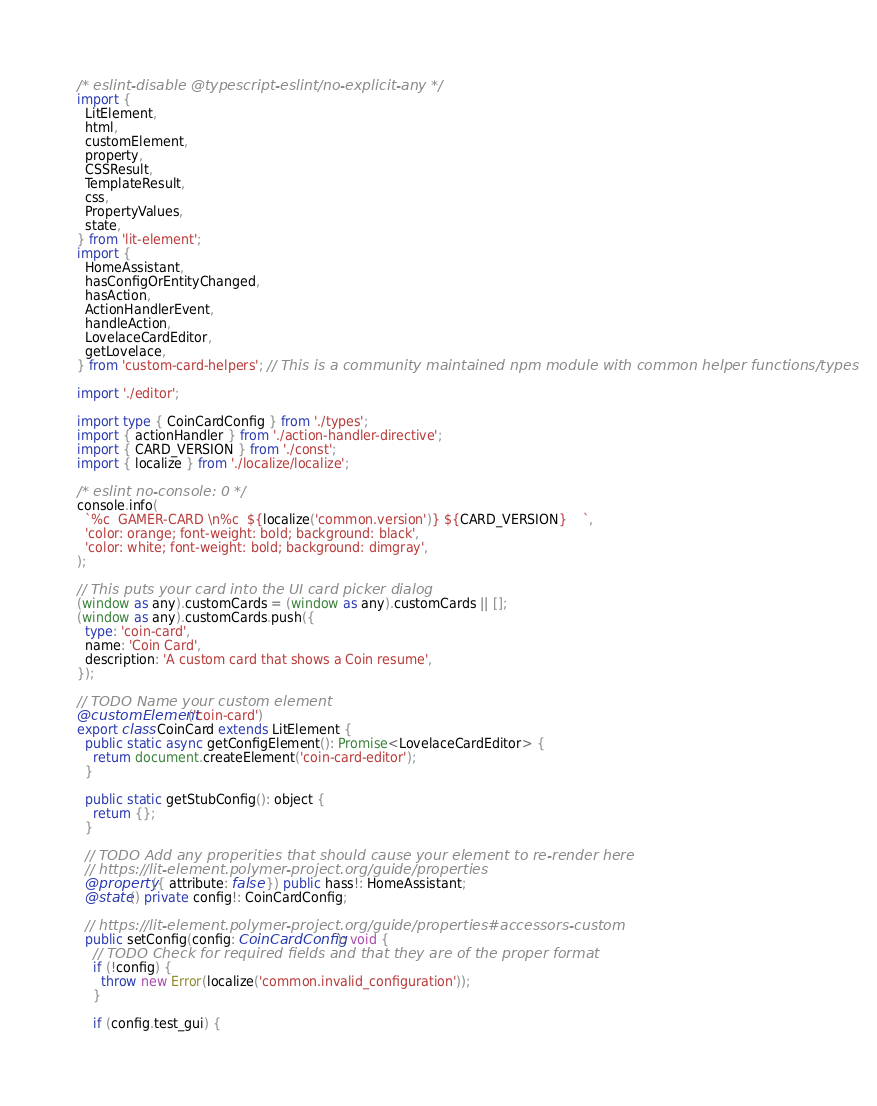Convert code to text. <code><loc_0><loc_0><loc_500><loc_500><_TypeScript_>/* eslint-disable @typescript-eslint/no-explicit-any */
import {
  LitElement,
  html,
  customElement,
  property,
  CSSResult,
  TemplateResult,
  css,
  PropertyValues,
  state,
} from 'lit-element';
import {
  HomeAssistant,
  hasConfigOrEntityChanged,
  hasAction,
  ActionHandlerEvent,
  handleAction,
  LovelaceCardEditor,
  getLovelace,
} from 'custom-card-helpers'; // This is a community maintained npm module with common helper functions/types

import './editor';

import type { CoinCardConfig } from './types';
import { actionHandler } from './action-handler-directive';
import { CARD_VERSION } from './const';
import { localize } from './localize/localize';

/* eslint no-console: 0 */
console.info(
  `%c  GAMER-CARD \n%c  ${localize('common.version')} ${CARD_VERSION}    `,
  'color: orange; font-weight: bold; background: black',
  'color: white; font-weight: bold; background: dimgray',
);

// This puts your card into the UI card picker dialog
(window as any).customCards = (window as any).customCards || [];
(window as any).customCards.push({
  type: 'coin-card',
  name: 'Coin Card',
  description: 'A custom card that shows a Coin resume',
});

// TODO Name your custom element
@customElement('coin-card')
export class CoinCard extends LitElement {
  public static async getConfigElement(): Promise<LovelaceCardEditor> {
    return document.createElement('coin-card-editor');
  }

  public static getStubConfig(): object {
    return {};
  }

  // TODO Add any properities that should cause your element to re-render here
  // https://lit-element.polymer-project.org/guide/properties
  @property({ attribute: false }) public hass!: HomeAssistant;
  @state() private config!: CoinCardConfig;

  // https://lit-element.polymer-project.org/guide/properties#accessors-custom
  public setConfig(config: CoinCardConfig): void {
    // TODO Check for required fields and that they are of the proper format
    if (!config) {
      throw new Error(localize('common.invalid_configuration'));
    }

    if (config.test_gui) {</code> 